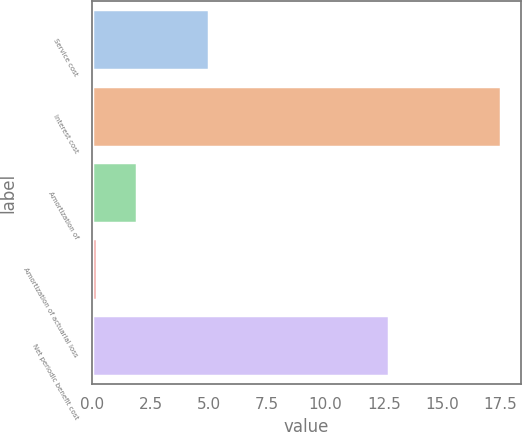Convert chart. <chart><loc_0><loc_0><loc_500><loc_500><bar_chart><fcel>Service cost<fcel>Interest cost<fcel>Amortization of<fcel>Amortization of actuarial loss<fcel>Net periodic benefit cost<nl><fcel>5<fcel>17.5<fcel>1.93<fcel>0.2<fcel>12.7<nl></chart> 